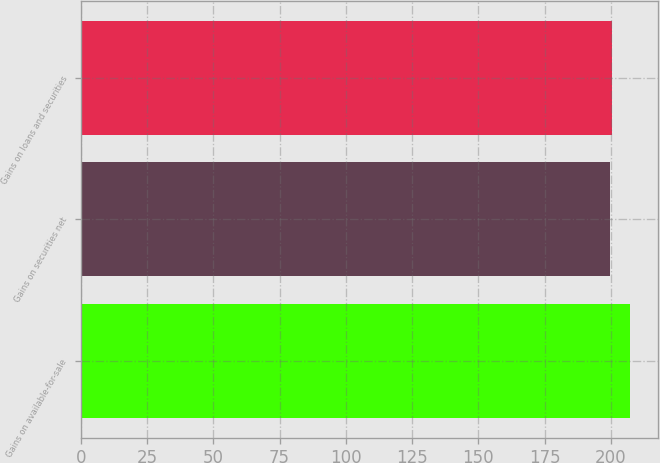<chart> <loc_0><loc_0><loc_500><loc_500><bar_chart><fcel>Gains on available-for-sale<fcel>Gains on securities net<fcel>Gains on loans and securities<nl><fcel>207.3<fcel>199.8<fcel>200.55<nl></chart> 